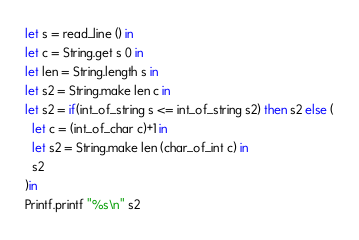<code> <loc_0><loc_0><loc_500><loc_500><_OCaml_>let s = read_line () in
let c = String.get s 0 in
let len = String.length s in
let s2 = String.make len c in
let s2 = if(int_of_string s <= int_of_string s2) then s2 else (
  let c = (int_of_char c)+1 in
  let s2 = String.make len (char_of_int c) in
  s2
)in
Printf.printf "%s\n" s2
</code> 